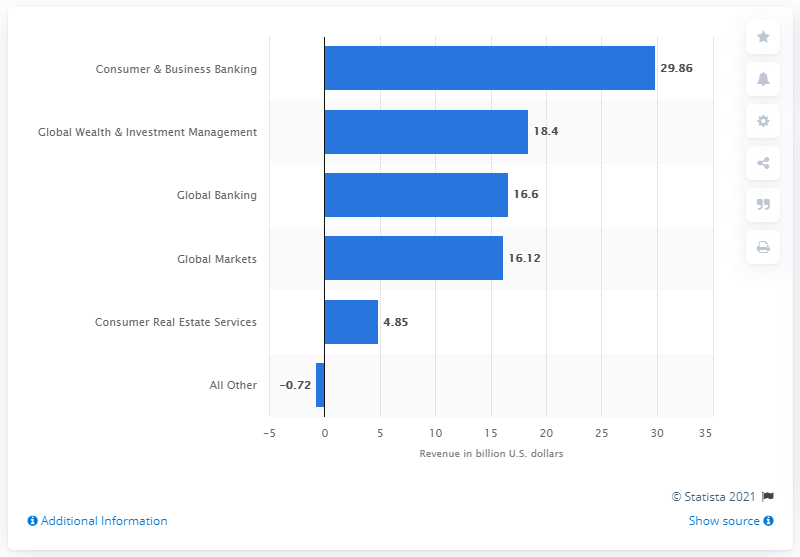List a handful of essential elements in this visual. In 2014, the revenue of the Consumer and Business Banking segment was 29.86. 